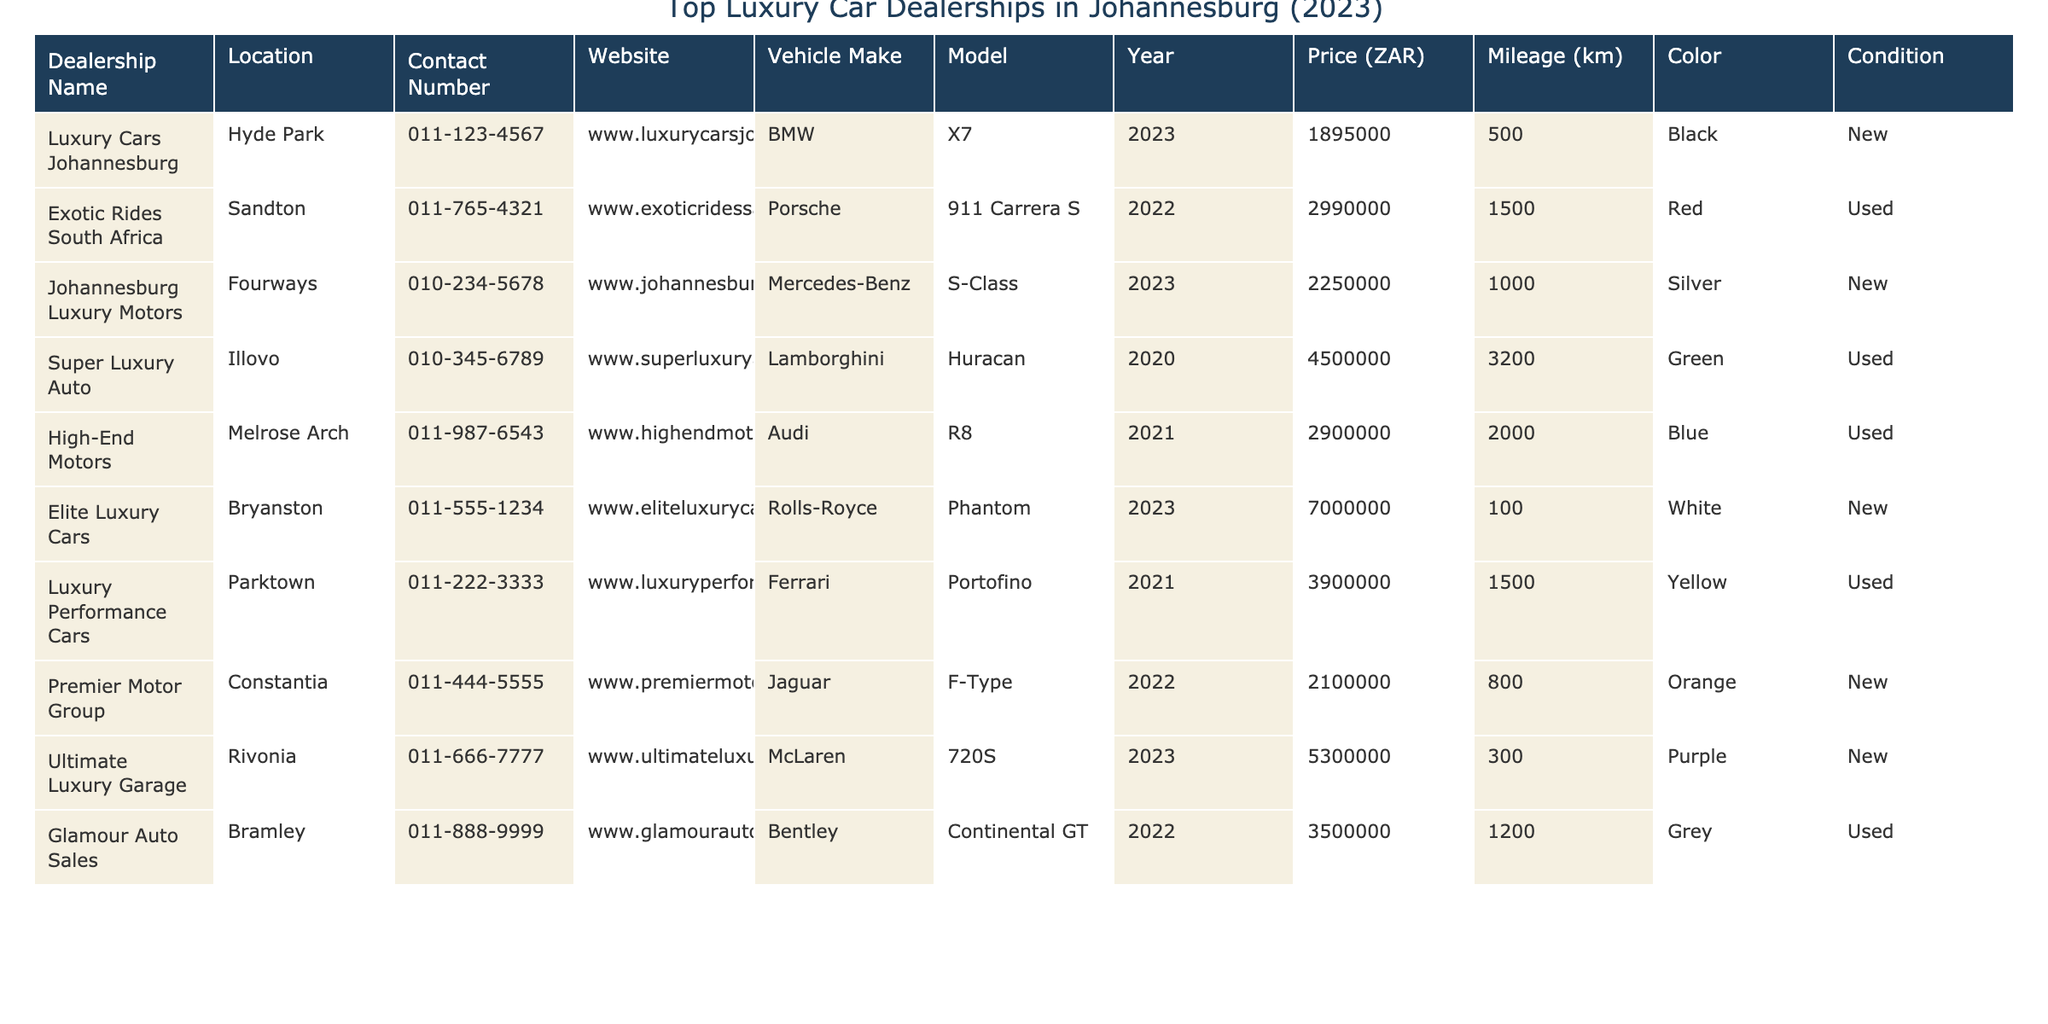What is the highest priced vehicle listed in the table? The table lists several vehicles with prices. By scanning the 'Price (ZAR)' column, the highest price noted is for the Rolls-Royce Phantom at 7,000,000 ZAR.
Answer: 7,000,000 ZAR How many vehicles in the table are classified as 'New'? The 'Condition' column indicates whether vehicles are 'New' or 'Used'. Counting the entries, there are 6 vehicles marked as 'New'.
Answer: 6 What is the average price of the luxury vehicles in the table? To find the average, first sum all the prices listed: 1,895,000 + 2,990,000 + 2,250,000 + 4,500,000 + 2,900,000 + 7,000,000 + 3,900,000 + 2,100,000 + 5,300,000 + 3,500,000 = 33,325,000 ZAR. There are 10 vehicles, so the average price is 33,325,000 / 10 = 3,332,500 ZAR.
Answer: 3,332,500 ZAR Did any dealership list a Lamborghini for sale? The table shows a vehicle listing for a Lamborghini Huracan under 'Super Luxury Auto', confirming that a Lamborghini is available for sale.
Answer: Yes What is the price difference between the cheapest and the most expensive car? The cheapest car is the BMW X7 at 1,895,000 ZAR and the most expensive is the Rolls-Royce Phantom at 7,000,000 ZAR. The price difference is 7,000,000 - 1,895,000 = 5,105,000 ZAR.
Answer: 5,105,000 ZAR Which dealership has the lowest mileage vehicle, and what is its mileage? Scanning the 'Mileage (km)' column, the BMW X7 has the lowest mileage recorded at 500 km, which is listed under the dealership 'Luxury Cars Johannesburg'.
Answer: Luxury Cars Johannesburg, 500 km How many different vehicle makes are represented in the table? The table includes the vehicle makes: BMW, Porsche, Mercedes-Benz, Lamborghini, Audi, Rolls-Royce, Ferrari, Jaguar, and McLaren. This adds up to a total of 9 distinct makes.
Answer: 9 Is there any vehicle listed from 2023? Yes, by looking through the 'Year' column, there are three vehicles from 2023: BMW X7, Mercedes-Benz S-Class, and Rolls-Royce Phantom.
Answer: Yes Which vehicle has the highest mileage in the table? The 'Mileage (km)' column shows that the Lamborghini Huracan has the highest mileage at 3200 km.
Answer: Lamborghini Huracan, 3200 km What percentage of vehicles are classified as Used? There are 4 vehicles listed as Used out of 10 total vehicles. So, the percentage is (4 / 10) * 100 = 40%.
Answer: 40% 